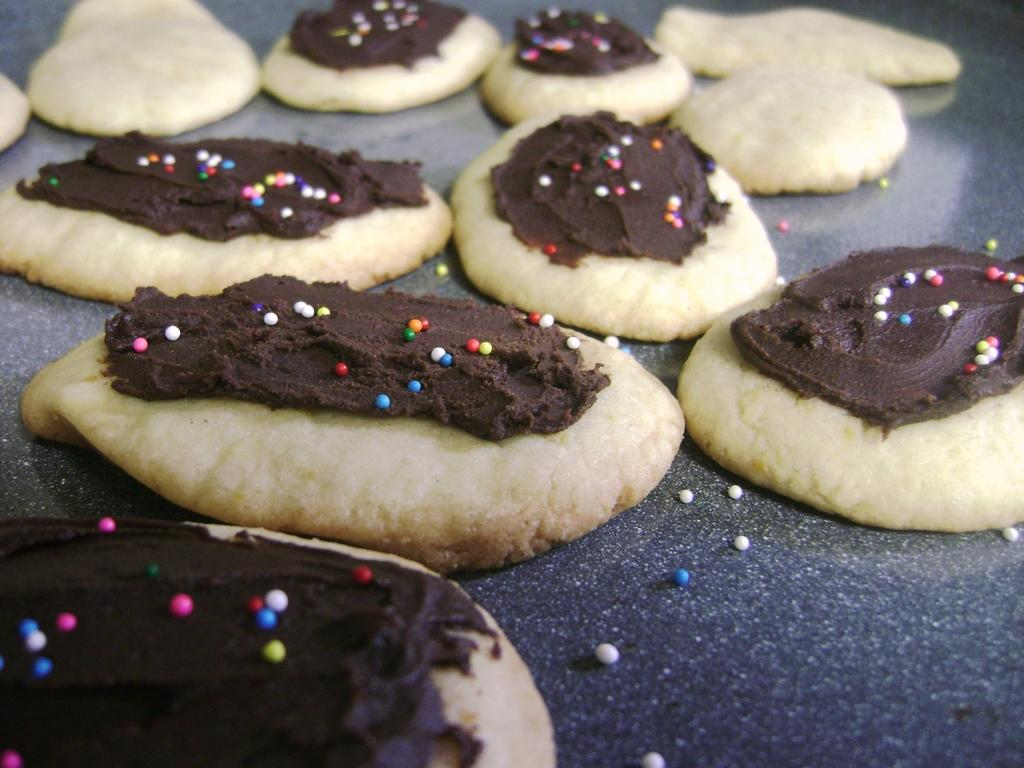What type of food is visible in the image? There are cookies in the image. What color is the shirt worn by the cookie in the image? There is no shirt worn by the cookie in the image, as cookies are inanimate objects and do not wear clothing. 